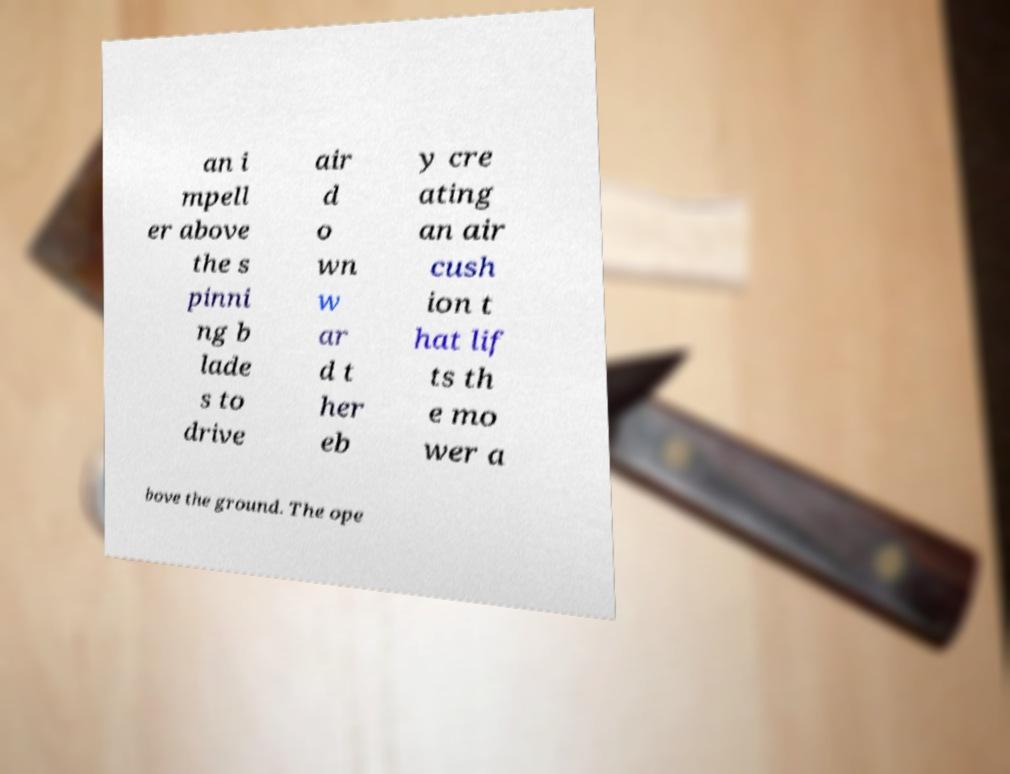Can you accurately transcribe the text from the provided image for me? an i mpell er above the s pinni ng b lade s to drive air d o wn w ar d t her eb y cre ating an air cush ion t hat lif ts th e mo wer a bove the ground. The ope 